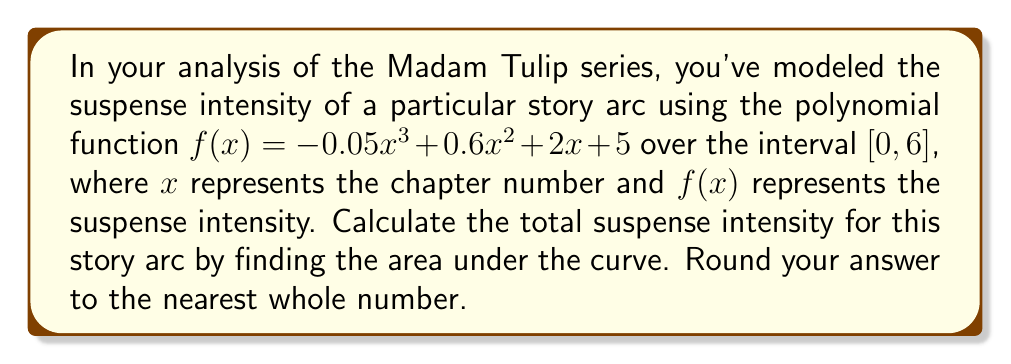Solve this math problem. To find the area under the curve, we need to integrate the function $f(x)$ over the given interval $[0, 6]$. Here's how we can do this step-by-step:

1) The integral of $f(x) = -0.05x^3 + 0.6x^2 + 2x + 5$ from 0 to 6 is:

   $$\int_0^6 (-0.05x^3 + 0.6x^2 + 2x + 5) dx$$

2) Integrate each term:
   $$\left[-0.05\frac{x^4}{4} + 0.6\frac{x^3}{3} + 2\frac{x^2}{2} + 5x\right]_0^6$$

3) Evaluate at the upper and lower bounds:
   $$\left(-0.05\frac{6^4}{4} + 0.6\frac{6^3}{3} + 2\frac{6^2}{2} + 5(6)\right) - \left(-0.05\frac{0^4}{4} + 0.6\frac{0^3}{3} + 2\frac{0^2}{2} + 5(0)\right)$$

4) Simplify:
   $$(-27 + 72 + 36 + 30) - (0)$$
   $$= 111$$

5) Round to the nearest whole number:
   111 (already a whole number)

Therefore, the total suspense intensity for this story arc is 111 units.
Answer: 111 